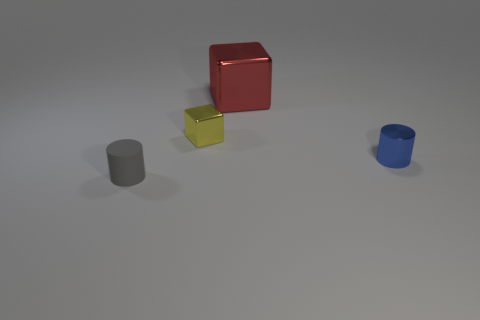Is the material of the tiny cylinder that is behind the matte thing the same as the gray thing?
Make the answer very short. No. What is the cylinder that is on the left side of the small block made of?
Ensure brevity in your answer.  Rubber. What is the size of the cylinder in front of the small metal thing that is in front of the small cube?
Keep it short and to the point. Small. How many other yellow metallic things are the same size as the yellow object?
Keep it short and to the point. 0. Are there any tiny blue objects left of the blue object?
Provide a short and direct response. No. What is the color of the thing that is both on the right side of the yellow metal cube and in front of the small yellow metallic thing?
Make the answer very short. Blue. Is the red object that is left of the small blue object made of the same material as the tiny object that is on the left side of the tiny yellow metallic block?
Offer a terse response. No. There is a cylinder in front of the metallic cylinder; what is its size?
Offer a terse response. Small. What is the size of the blue shiny cylinder?
Provide a succinct answer. Small. How big is the cylinder to the right of the thing that is in front of the tiny cylinder to the right of the gray rubber thing?
Your answer should be compact. Small. 